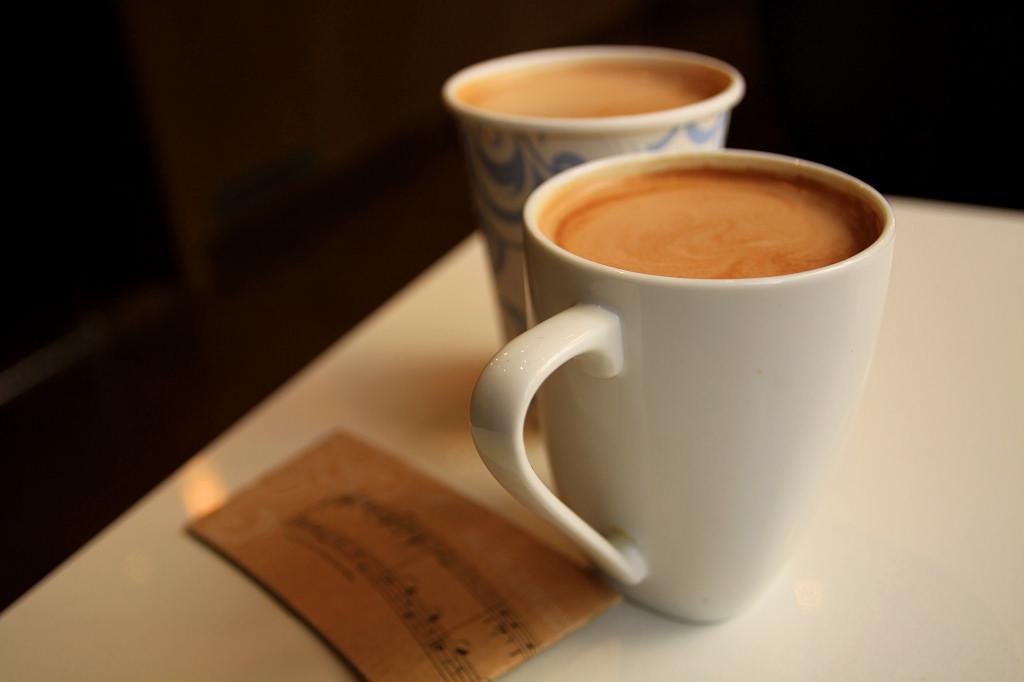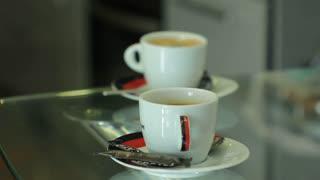The first image is the image on the left, the second image is the image on the right. Assess this claim about the two images: "There are four cups of hot drinks, and two of them are sitting on plates.". Correct or not? Answer yes or no. Yes. The first image is the image on the left, the second image is the image on the right. Considering the images on both sides, is "The pair of cups in the right image have no handles." valid? Answer yes or no. No. 